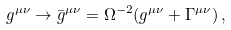Convert formula to latex. <formula><loc_0><loc_0><loc_500><loc_500>g ^ { \mu \nu } \rightarrow \bar { g } ^ { \mu \nu } = \Omega ^ { - 2 } ( g ^ { \mu \nu } + \Gamma ^ { \mu \nu } ) \, ,</formula> 